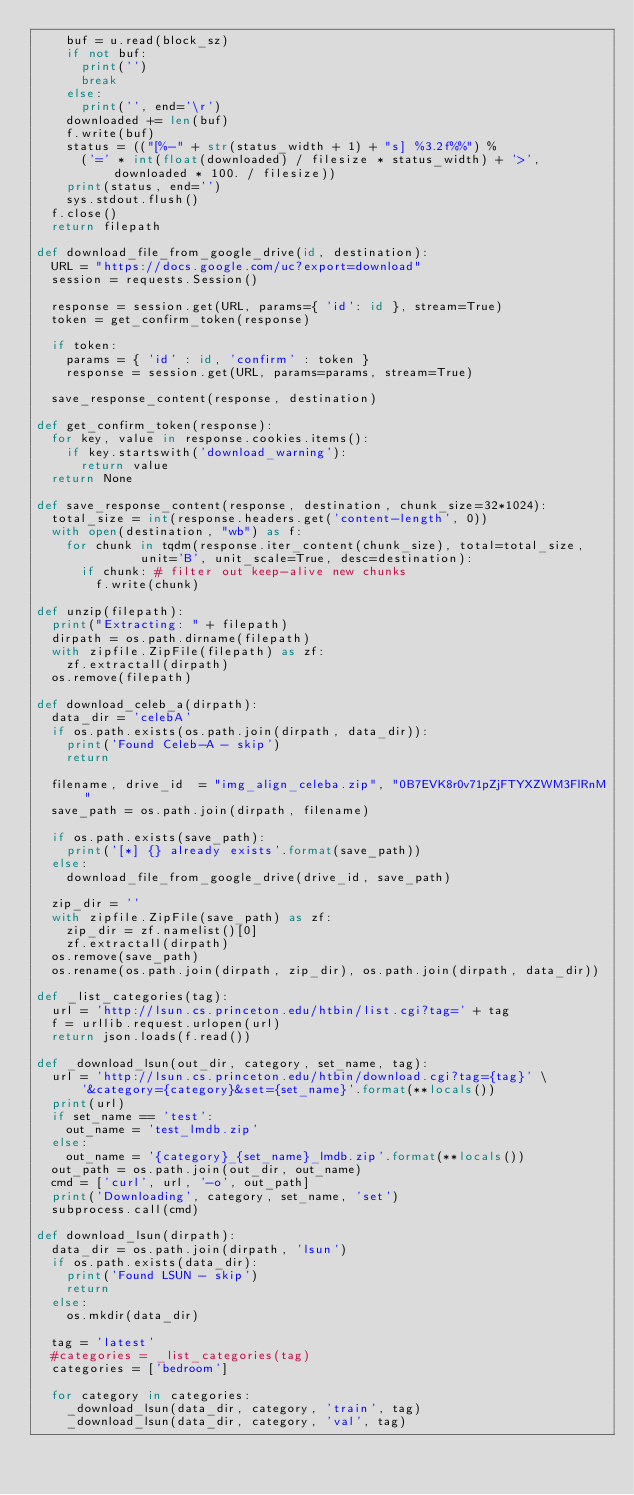<code> <loc_0><loc_0><loc_500><loc_500><_Python_>    buf = u.read(block_sz)
    if not buf:
      print('')
      break
    else:
      print('', end='\r')
    downloaded += len(buf)
    f.write(buf)
    status = (("[%-" + str(status_width + 1) + "s] %3.2f%%") %
      ('=' * int(float(downloaded) / filesize * status_width) + '>', downloaded * 100. / filesize))
    print(status, end='')
    sys.stdout.flush()
  f.close()
  return filepath

def download_file_from_google_drive(id, destination):
  URL = "https://docs.google.com/uc?export=download"
  session = requests.Session()

  response = session.get(URL, params={ 'id': id }, stream=True)
  token = get_confirm_token(response)

  if token:
    params = { 'id' : id, 'confirm' : token }
    response = session.get(URL, params=params, stream=True)

  save_response_content(response, destination)

def get_confirm_token(response):
  for key, value in response.cookies.items():
    if key.startswith('download_warning'):
      return value
  return None

def save_response_content(response, destination, chunk_size=32*1024):
  total_size = int(response.headers.get('content-length', 0))
  with open(destination, "wb") as f:
    for chunk in tqdm(response.iter_content(chunk_size), total=total_size,
              unit='B', unit_scale=True, desc=destination):
      if chunk: # filter out keep-alive new chunks
        f.write(chunk)

def unzip(filepath):
  print("Extracting: " + filepath)
  dirpath = os.path.dirname(filepath)
  with zipfile.ZipFile(filepath) as zf:
    zf.extractall(dirpath)
  os.remove(filepath)

def download_celeb_a(dirpath):
  data_dir = 'celebA'
  if os.path.exists(os.path.join(dirpath, data_dir)):
    print('Found Celeb-A - skip')
    return

  filename, drive_id  = "img_align_celeba.zip", "0B7EVK8r0v71pZjFTYXZWM3FlRnM"
  save_path = os.path.join(dirpath, filename)

  if os.path.exists(save_path):
    print('[*] {} already exists'.format(save_path))
  else:
    download_file_from_google_drive(drive_id, save_path)

  zip_dir = ''
  with zipfile.ZipFile(save_path) as zf:
    zip_dir = zf.namelist()[0]
    zf.extractall(dirpath)
  os.remove(save_path)
  os.rename(os.path.join(dirpath, zip_dir), os.path.join(dirpath, data_dir))

def _list_categories(tag):
  url = 'http://lsun.cs.princeton.edu/htbin/list.cgi?tag=' + tag
  f = urllib.request.urlopen(url)
  return json.loads(f.read())

def _download_lsun(out_dir, category, set_name, tag):
  url = 'http://lsun.cs.princeton.edu/htbin/download.cgi?tag={tag}' \
      '&category={category}&set={set_name}'.format(**locals())
  print(url)
  if set_name == 'test':
    out_name = 'test_lmdb.zip'
  else:
    out_name = '{category}_{set_name}_lmdb.zip'.format(**locals())
  out_path = os.path.join(out_dir, out_name)
  cmd = ['curl', url, '-o', out_path]
  print('Downloading', category, set_name, 'set')
  subprocess.call(cmd)

def download_lsun(dirpath):
  data_dir = os.path.join(dirpath, 'lsun')
  if os.path.exists(data_dir):
    print('Found LSUN - skip')
    return
  else:
    os.mkdir(data_dir)

  tag = 'latest'
  #categories = _list_categories(tag)
  categories = ['bedroom']

  for category in categories:
    _download_lsun(data_dir, category, 'train', tag)
    _download_lsun(data_dir, category, 'val', tag)</code> 